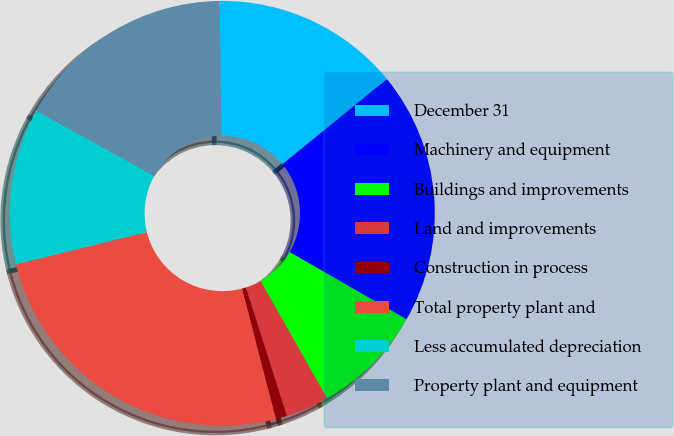Convert chart to OTSL. <chart><loc_0><loc_0><loc_500><loc_500><pie_chart><fcel>December 31<fcel>Machinery and equipment<fcel>Buildings and improvements<fcel>Land and improvements<fcel>Construction in process<fcel>Total property plant and<fcel>Less accumulated depreciation<fcel>Property plant and equipment<nl><fcel>14.32%<fcel>19.19%<fcel>8.49%<fcel>3.29%<fcel>0.85%<fcel>25.21%<fcel>11.89%<fcel>16.76%<nl></chart> 